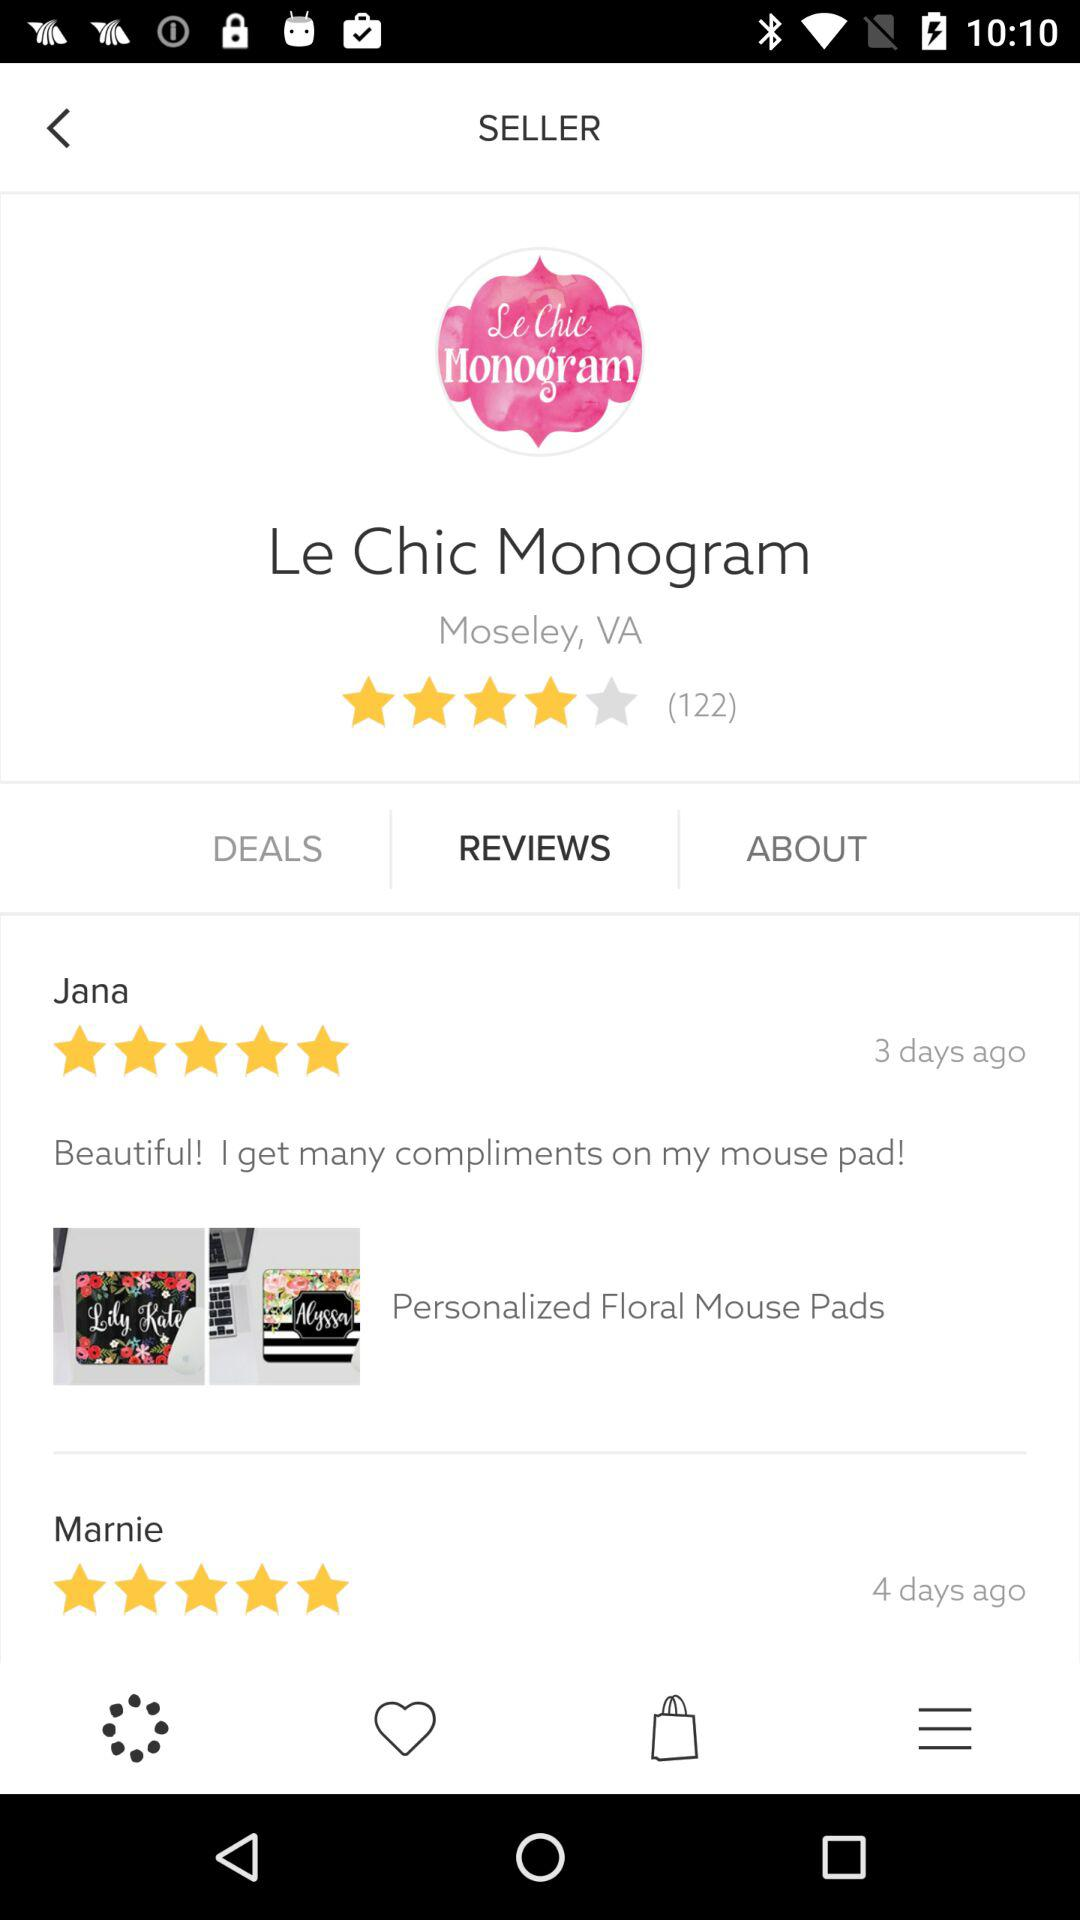How many reviews are there for this product?
Answer the question using a single word or phrase. 122 